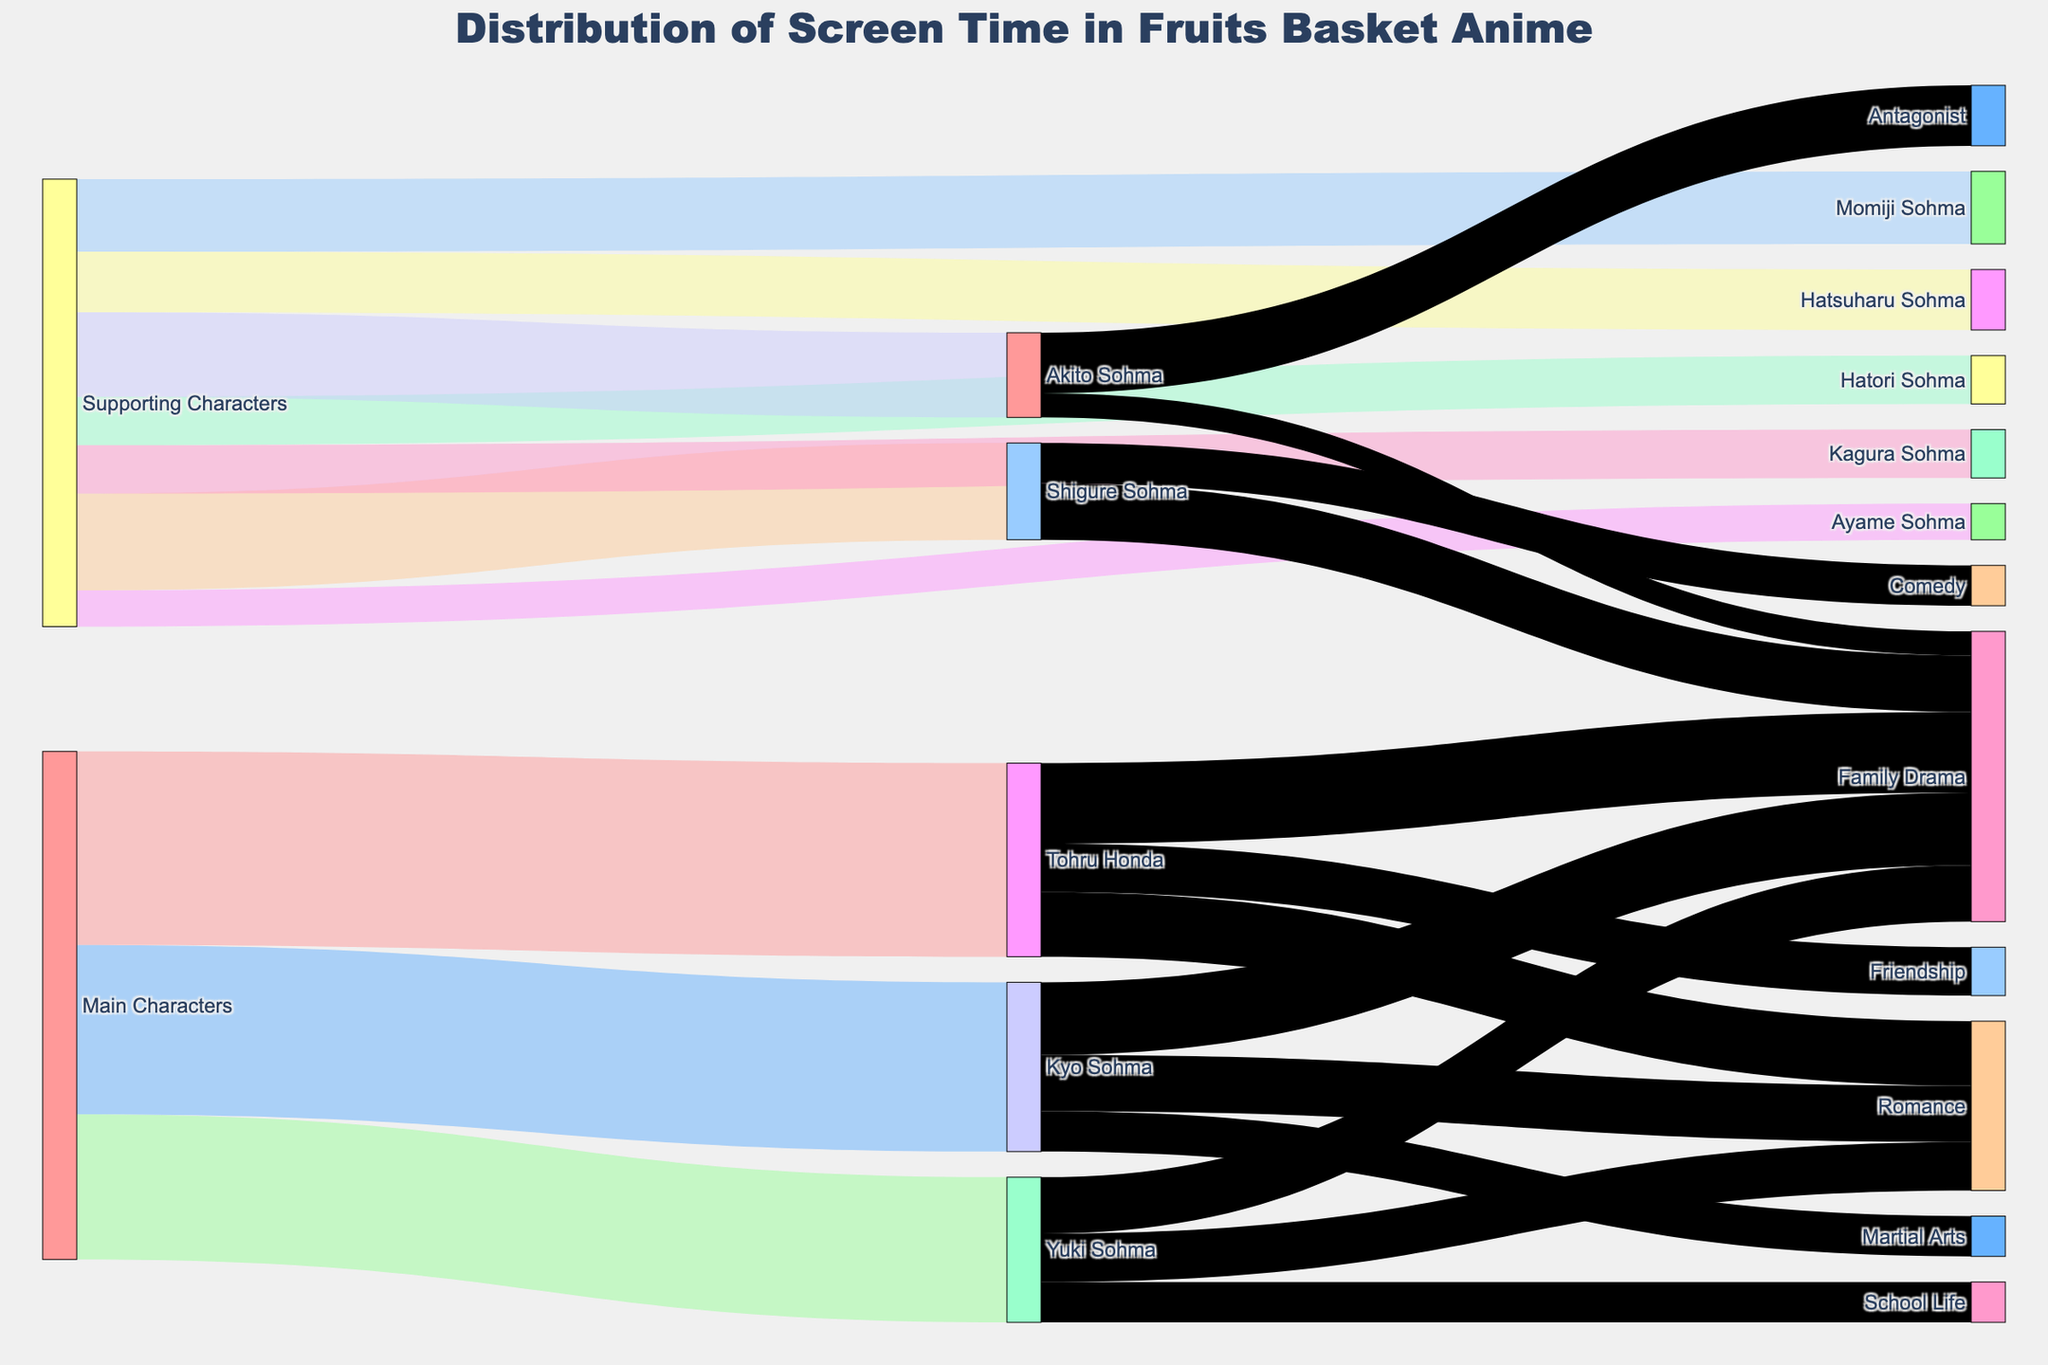What is the title of the figure? The title of the figure is displayed at the top of the Sankey Diagram, and it reads "Distribution of Screen Time in Fruits Basket Anime".
Answer: Distribution of Screen Time in Fruits Basket Anime Which character has the highest screen time among the main characters? By examining the Sankey Diagram, you can see that Tohru Honda has the largest value among the main characters.
Answer: Tohru Honda What is the total screen time for all the main characters combined? You need to sum the screen times for Tohru Honda (240), Kyo Sohma (210), and Yuki Sohma (180). This gives you 240 + 210 + 180 = 630.
Answer: 630 What is the total screen time dedicated to the theme of Family Drama for all characters? Sum the Family Drama screen times: Tohru Honda (100), Kyo Sohma (90), Yuki Sohma (70), Shigure Sohma (70), and Akito Sohma (30). This gives you 100 + 90 + 70 + 70 + 30 = 360.
Answer: 360 Who has more screen time: Kagura Sohma or Hatsuharu Sohma? From the diagram, Kagura Sohma has 60 units of screen time while Hatsuharu Sohma has 75 units. Therefore, Hatsuharu Sohma has more screen time.
Answer: Hatsuharu Sohma Which theme has more screen time: Romance or Family Drama for Tohru Honda? Tohru Honda's Romance theme has 80 units of screen time, while Family Drama has 100 units. Therefore, Family Drama has more screen time.
Answer: Family Drama Which supporting character is linked to the highest number of different themes? By observing the outgoing flows from each supporting character, Shigure Sohma has two themes connected: Comedy and Family Drama. The other supporting characters that are labeled do not have multiple themes.
Answer: Shigure Sohma What is the total screen time linked to the character Akito Sohma, and how is it distributed among the themes? The diagram shows Akito Sohma's total screen time is 105. It is distributed as 75 to Antagonist and 30 to Family Drama.
Answer: 105 distributed as 75 to Antagonist and 30 to Family Drama Which character has the least screen time among the supporting characters? By looking at the Sankey Diagram, Ayame Sohma has the least screen time among supporting characters with 45 units.
Answer: Ayame Sohma 